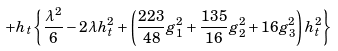Convert formula to latex. <formula><loc_0><loc_0><loc_500><loc_500>+ h _ { t } \left \{ \frac { \lambda ^ { 2 } } { 6 } - 2 \lambda h _ { t } ^ { 2 } + \left ( \frac { 2 2 3 } { 4 8 } g _ { 1 } ^ { 2 } + \frac { 1 3 5 } { 1 6 } g _ { 2 } ^ { 2 } + 1 6 g _ { 3 } ^ { 2 } \right ) h _ { t } ^ { 2 } \right \}</formula> 